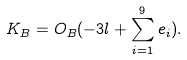Convert formula to latex. <formula><loc_0><loc_0><loc_500><loc_500>K _ { B } = O _ { B } ( - 3 l + \sum _ { i = 1 } ^ { 9 } e _ { i } ) .</formula> 